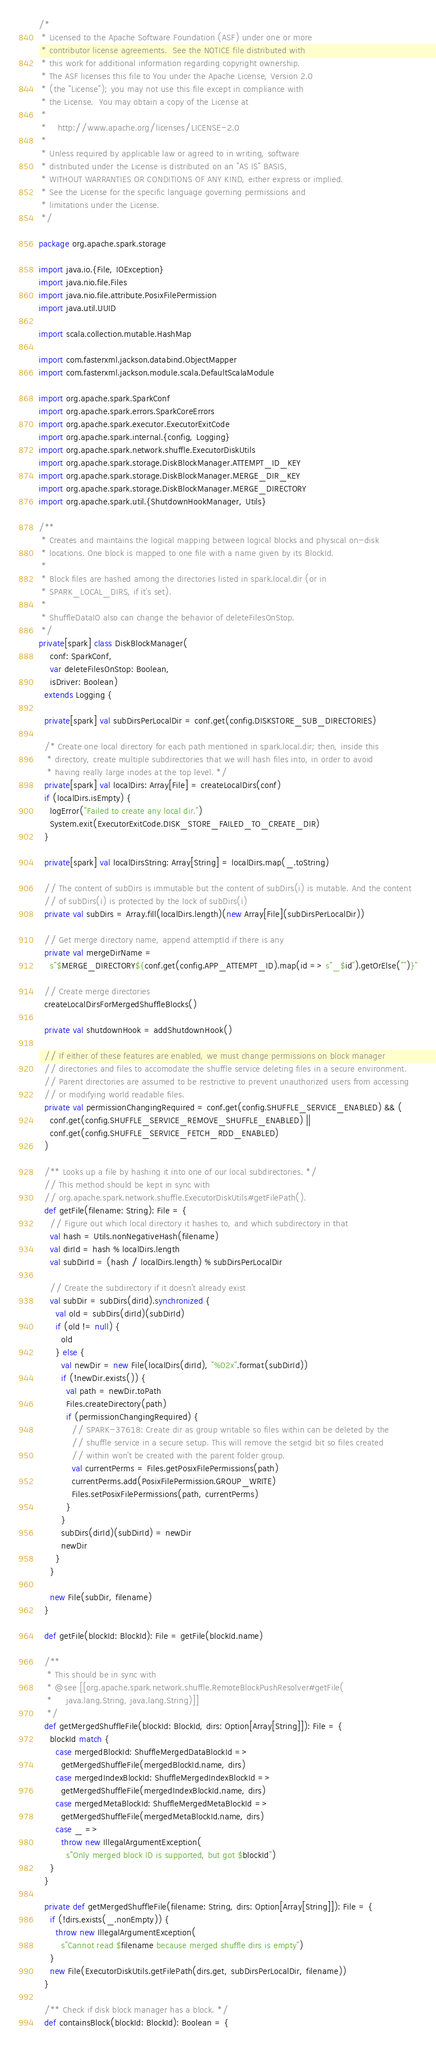<code> <loc_0><loc_0><loc_500><loc_500><_Scala_>/*
 * Licensed to the Apache Software Foundation (ASF) under one or more
 * contributor license agreements.  See the NOTICE file distributed with
 * this work for additional information regarding copyright ownership.
 * The ASF licenses this file to You under the Apache License, Version 2.0
 * (the "License"); you may not use this file except in compliance with
 * the License.  You may obtain a copy of the License at
 *
 *    http://www.apache.org/licenses/LICENSE-2.0
 *
 * Unless required by applicable law or agreed to in writing, software
 * distributed under the License is distributed on an "AS IS" BASIS,
 * WITHOUT WARRANTIES OR CONDITIONS OF ANY KIND, either express or implied.
 * See the License for the specific language governing permissions and
 * limitations under the License.
 */

package org.apache.spark.storage

import java.io.{File, IOException}
import java.nio.file.Files
import java.nio.file.attribute.PosixFilePermission
import java.util.UUID

import scala.collection.mutable.HashMap

import com.fasterxml.jackson.databind.ObjectMapper
import com.fasterxml.jackson.module.scala.DefaultScalaModule

import org.apache.spark.SparkConf
import org.apache.spark.errors.SparkCoreErrors
import org.apache.spark.executor.ExecutorExitCode
import org.apache.spark.internal.{config, Logging}
import org.apache.spark.network.shuffle.ExecutorDiskUtils
import org.apache.spark.storage.DiskBlockManager.ATTEMPT_ID_KEY
import org.apache.spark.storage.DiskBlockManager.MERGE_DIR_KEY
import org.apache.spark.storage.DiskBlockManager.MERGE_DIRECTORY
import org.apache.spark.util.{ShutdownHookManager, Utils}

/**
 * Creates and maintains the logical mapping between logical blocks and physical on-disk
 * locations. One block is mapped to one file with a name given by its BlockId.
 *
 * Block files are hashed among the directories listed in spark.local.dir (or in
 * SPARK_LOCAL_DIRS, if it's set).
 *
 * ShuffleDataIO also can change the behavior of deleteFilesOnStop.
 */
private[spark] class DiskBlockManager(
    conf: SparkConf,
    var deleteFilesOnStop: Boolean,
    isDriver: Boolean)
  extends Logging {

  private[spark] val subDirsPerLocalDir = conf.get(config.DISKSTORE_SUB_DIRECTORIES)

  /* Create one local directory for each path mentioned in spark.local.dir; then, inside this
   * directory, create multiple subdirectories that we will hash files into, in order to avoid
   * having really large inodes at the top level. */
  private[spark] val localDirs: Array[File] = createLocalDirs(conf)
  if (localDirs.isEmpty) {
    logError("Failed to create any local dir.")
    System.exit(ExecutorExitCode.DISK_STORE_FAILED_TO_CREATE_DIR)
  }

  private[spark] val localDirsString: Array[String] = localDirs.map(_.toString)

  // The content of subDirs is immutable but the content of subDirs(i) is mutable. And the content
  // of subDirs(i) is protected by the lock of subDirs(i)
  private val subDirs = Array.fill(localDirs.length)(new Array[File](subDirsPerLocalDir))

  // Get merge directory name, append attemptId if there is any
  private val mergeDirName =
    s"$MERGE_DIRECTORY${conf.get(config.APP_ATTEMPT_ID).map(id => s"_$id").getOrElse("")}"

  // Create merge directories
  createLocalDirsForMergedShuffleBlocks()

  private val shutdownHook = addShutdownHook()

  // If either of these features are enabled, we must change permissions on block manager
  // directories and files to accomodate the shuffle service deleting files in a secure environment.
  // Parent directories are assumed to be restrictive to prevent unauthorized users from accessing
  // or modifying world readable files.
  private val permissionChangingRequired = conf.get(config.SHUFFLE_SERVICE_ENABLED) && (
    conf.get(config.SHUFFLE_SERVICE_REMOVE_SHUFFLE_ENABLED) ||
    conf.get(config.SHUFFLE_SERVICE_FETCH_RDD_ENABLED)
  )

  /** Looks up a file by hashing it into one of our local subdirectories. */
  // This method should be kept in sync with
  // org.apache.spark.network.shuffle.ExecutorDiskUtils#getFilePath().
  def getFile(filename: String): File = {
    // Figure out which local directory it hashes to, and which subdirectory in that
    val hash = Utils.nonNegativeHash(filename)
    val dirId = hash % localDirs.length
    val subDirId = (hash / localDirs.length) % subDirsPerLocalDir

    // Create the subdirectory if it doesn't already exist
    val subDir = subDirs(dirId).synchronized {
      val old = subDirs(dirId)(subDirId)
      if (old != null) {
        old
      } else {
        val newDir = new File(localDirs(dirId), "%02x".format(subDirId))
        if (!newDir.exists()) {
          val path = newDir.toPath
          Files.createDirectory(path)
          if (permissionChangingRequired) {
            // SPARK-37618: Create dir as group writable so files within can be deleted by the
            // shuffle service in a secure setup. This will remove the setgid bit so files created
            // within won't be created with the parent folder group.
            val currentPerms = Files.getPosixFilePermissions(path)
            currentPerms.add(PosixFilePermission.GROUP_WRITE)
            Files.setPosixFilePermissions(path, currentPerms)
          }
        }
        subDirs(dirId)(subDirId) = newDir
        newDir
      }
    }

    new File(subDir, filename)
  }

  def getFile(blockId: BlockId): File = getFile(blockId.name)

  /**
   * This should be in sync with
   * @see [[org.apache.spark.network.shuffle.RemoteBlockPushResolver#getFile(
   *     java.lang.String, java.lang.String)]]
   */
  def getMergedShuffleFile(blockId: BlockId, dirs: Option[Array[String]]): File = {
    blockId match {
      case mergedBlockId: ShuffleMergedDataBlockId =>
        getMergedShuffleFile(mergedBlockId.name, dirs)
      case mergedIndexBlockId: ShuffleMergedIndexBlockId =>
        getMergedShuffleFile(mergedIndexBlockId.name, dirs)
      case mergedMetaBlockId: ShuffleMergedMetaBlockId =>
        getMergedShuffleFile(mergedMetaBlockId.name, dirs)
      case _ =>
        throw new IllegalArgumentException(
          s"Only merged block ID is supported, but got $blockId")
    }
  }

  private def getMergedShuffleFile(filename: String, dirs: Option[Array[String]]): File = {
    if (!dirs.exists(_.nonEmpty)) {
      throw new IllegalArgumentException(
        s"Cannot read $filename because merged shuffle dirs is empty")
    }
    new File(ExecutorDiskUtils.getFilePath(dirs.get, subDirsPerLocalDir, filename))
  }

  /** Check if disk block manager has a block. */
  def containsBlock(blockId: BlockId): Boolean = {</code> 